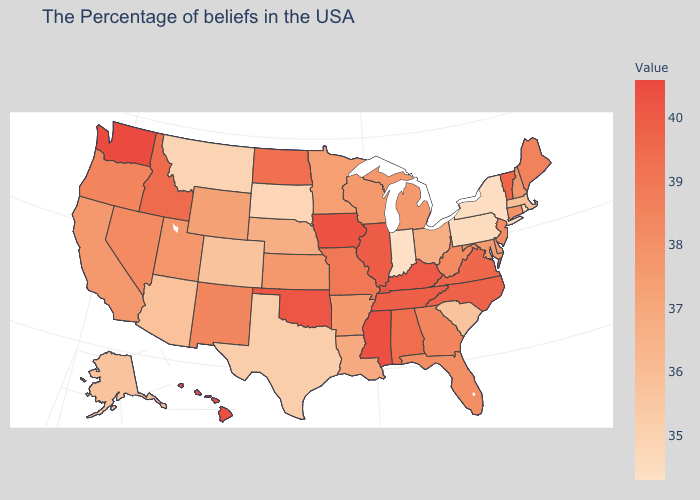Which states have the lowest value in the USA?
Concise answer only. Indiana. Does the map have missing data?
Keep it brief. No. Which states have the lowest value in the USA?
Write a very short answer. Indiana. Does Missouri have a lower value than Delaware?
Concise answer only. No. Which states have the highest value in the USA?
Write a very short answer. Washington. Among the states that border Montana , does Wyoming have the lowest value?
Short answer required. No. Does California have the highest value in the West?
Quick response, please. No. 